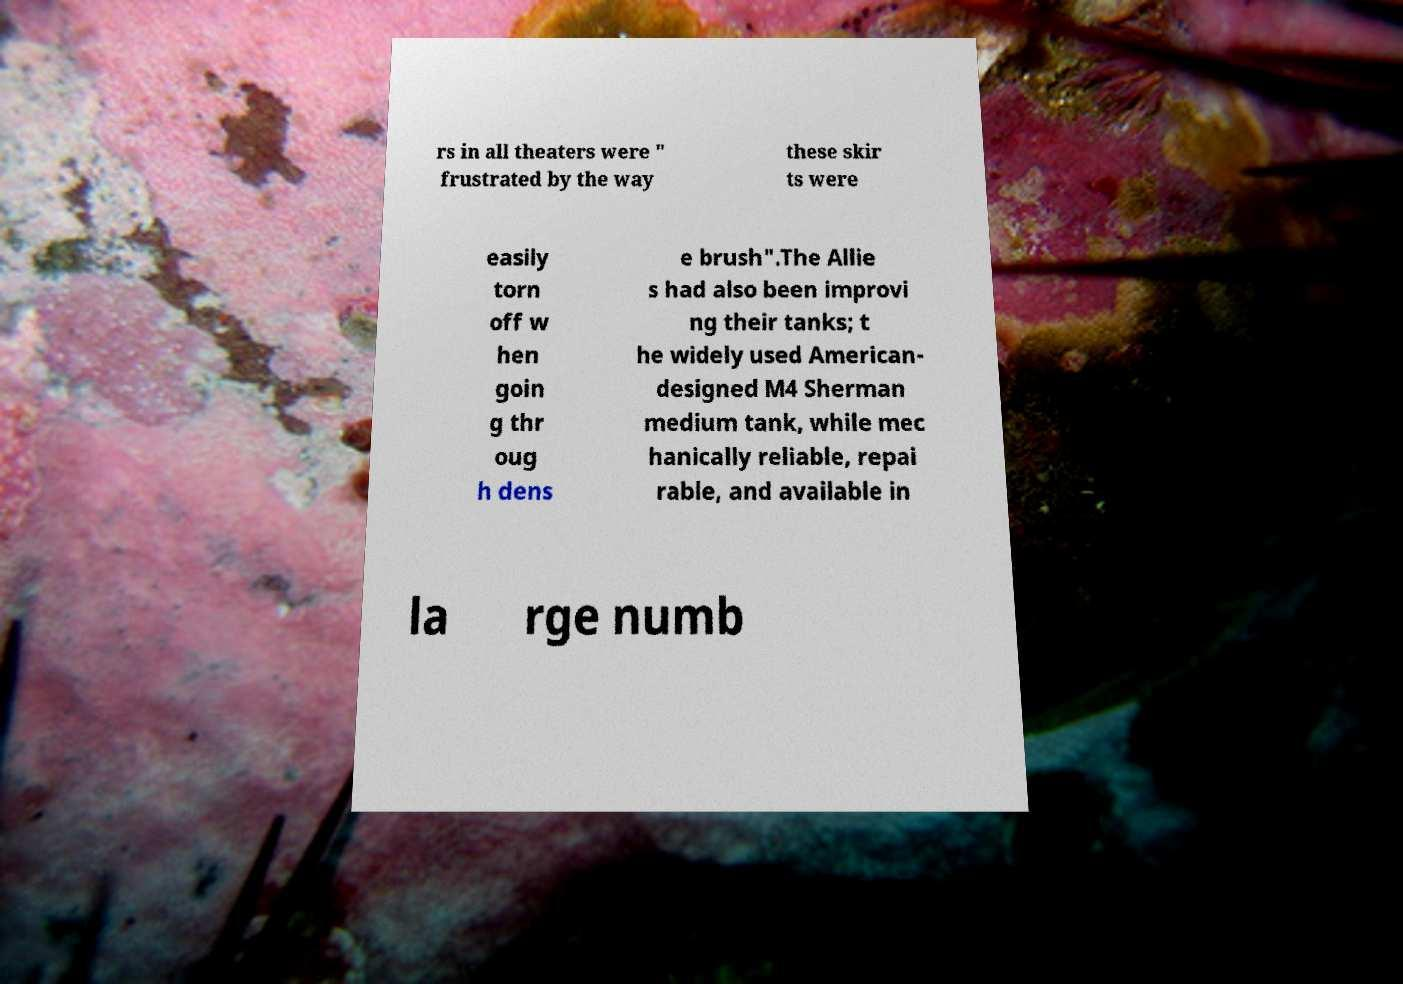For documentation purposes, I need the text within this image transcribed. Could you provide that? rs in all theaters were " frustrated by the way these skir ts were easily torn off w hen goin g thr oug h dens e brush".The Allie s had also been improvi ng their tanks; t he widely used American- designed M4 Sherman medium tank, while mec hanically reliable, repai rable, and available in la rge numb 